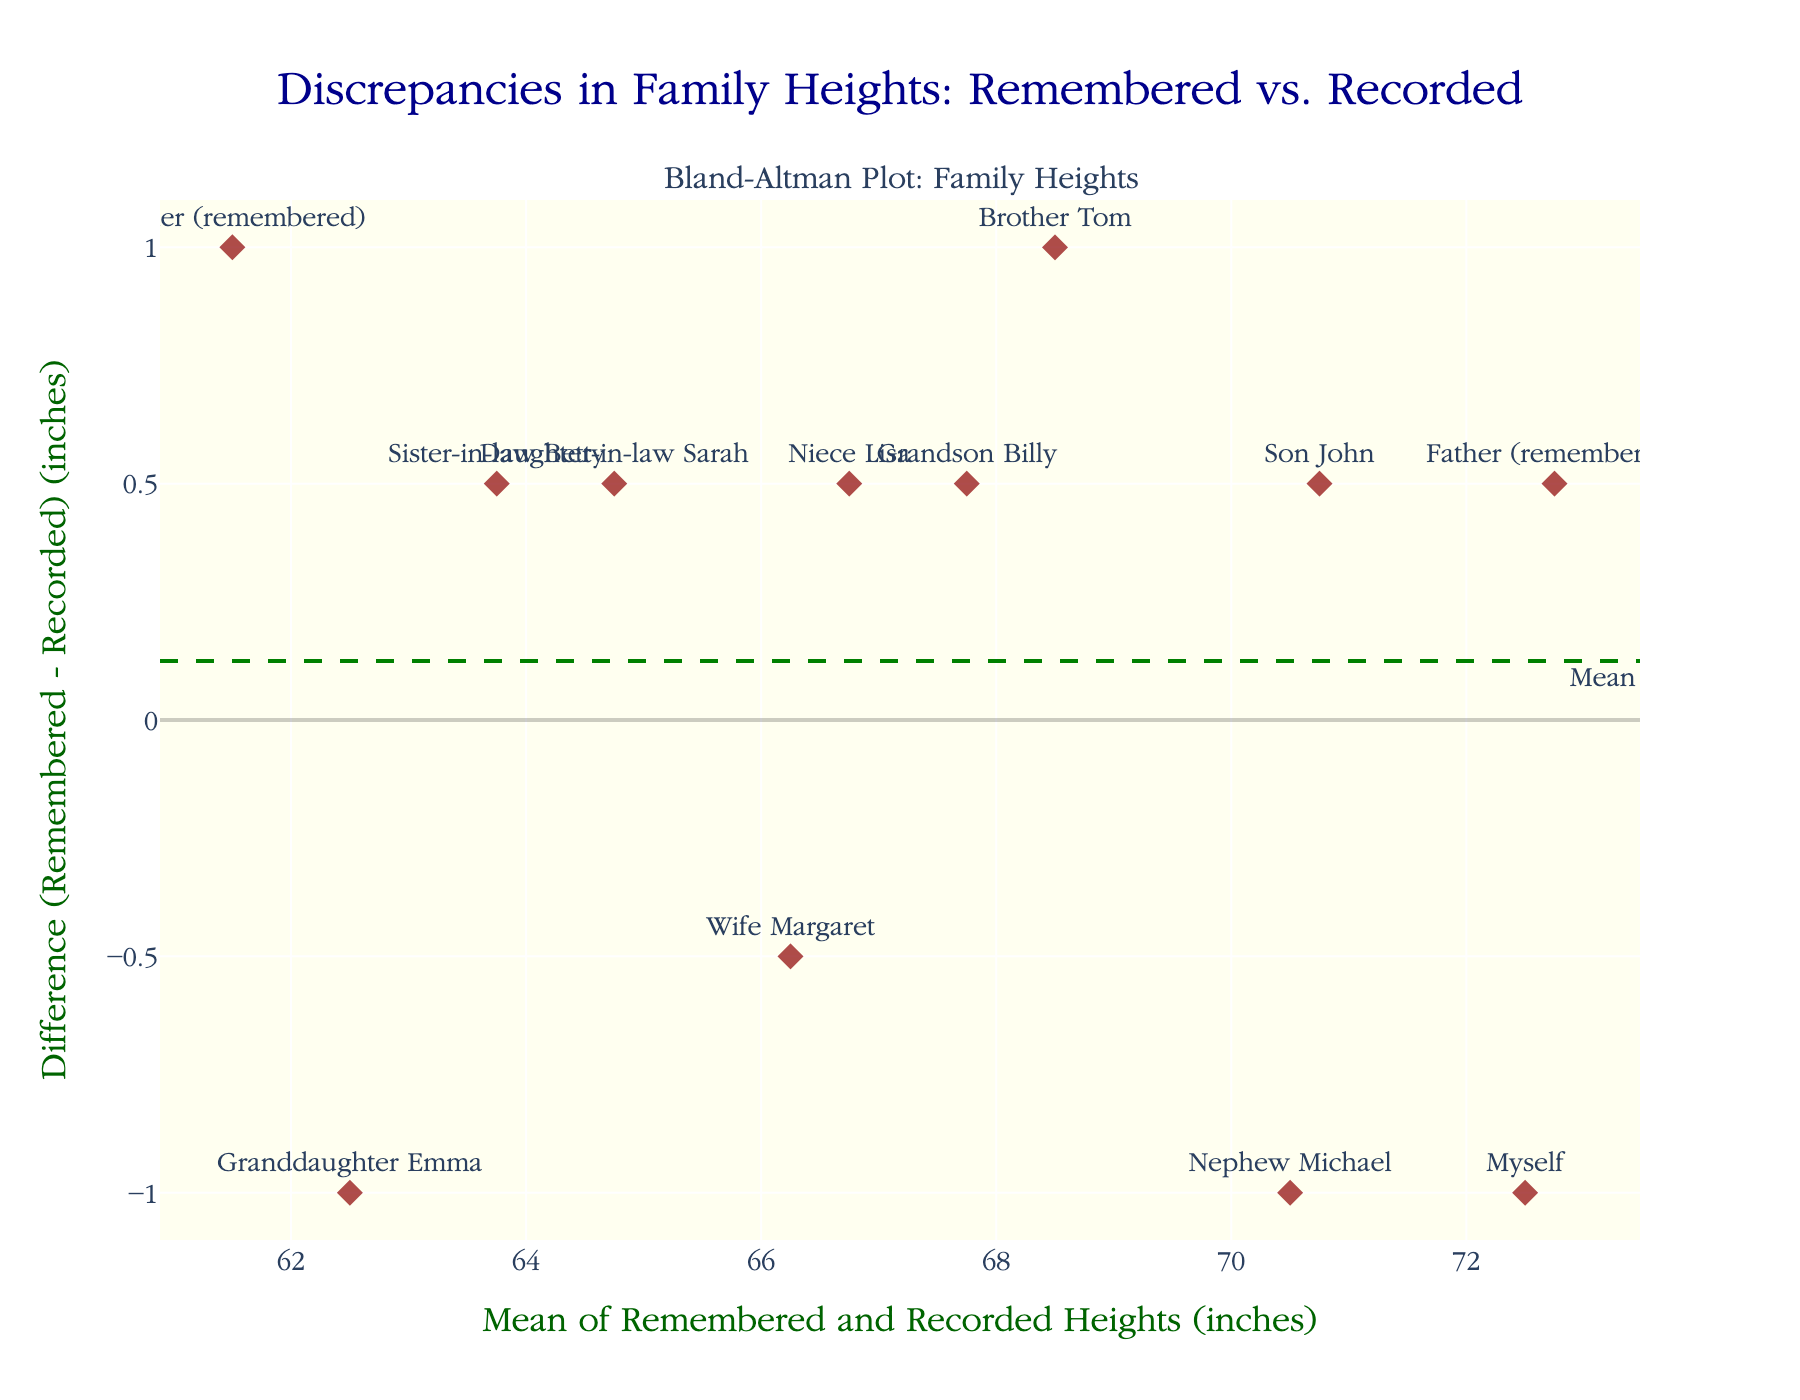What's the title of the plot? The title of the plot is displayed at the top center of the plot. It reads "Discrepancies in Family Heights: Remembered vs. Recorded."
Answer: Discrepancies in Family Heights: Remembered vs. Recorded What is the mean difference line labeled as and in what color? The mean difference line is labeled as "Mean" and is colored green.
Answer: Mean, green What is the range of the mean (x-axis)? The x-axis range is determined by examining the minimum and maximum values, which vary from approximately 60 to 73 inches based on the axis limits.
Answer: ~60 to 73 inches How are the discrepancies (difference between remembered and recorded heights) distributed overall? By looking at the data points plotted on the y-axis, one can see that most of the discrepancies (positive or negative) are within the upper and lower limits of agreement, i.e., generally small discrepancies.
Answer: Most are small, within limits Which family member shows the highest positive discrepancy between remembered and recorded height? By examining the data points and their corresponding labels, "Myself" has the highest point above zero on the y-axis, indicating the greatest positive discrepancy.
Answer: Myself Which family member shows the greatest negative discrepancy? By looking at the data points below zero, "Granddaughter Emma" is the lowest, indicating the greatest negative discrepancy.
Answer: Granddaughter Emma What are the upper and lower limits of agreement, and how are they calculated? The upper and lower limits of agreement (LOA) are calculated using the mean difference plus or minus 1.96 times the standard deviation of the differences. The plot shows dashed red lines at these values.
Answer: Upper LOA and Lower LOA, derived from mean ± 1.96 SD What is the general trend in discrepancies across different family members? Most labels (family members) are randomly above and below the mean line, indicating no clear trend based on family member age or status.
Answer: No clear trend Which family member's height discrepancy is closest to the mean line? By examining the data points and their closeness to the dashed green line, "Son John" is closest to the mean difference line.
Answer: Son John 